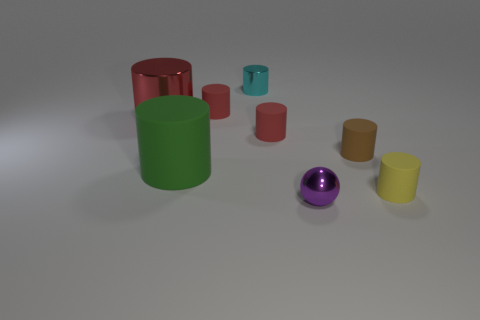How many red cylinders must be subtracted to get 1 red cylinders? 2 Subtract all red blocks. How many red cylinders are left? 3 Subtract all metal cylinders. How many cylinders are left? 5 Subtract 3 cylinders. How many cylinders are left? 4 Subtract all yellow cylinders. How many cylinders are left? 6 Add 1 green cylinders. How many objects exist? 9 Subtract all purple cylinders. Subtract all gray spheres. How many cylinders are left? 7 Add 5 big shiny cylinders. How many big shiny cylinders are left? 6 Add 8 gray shiny balls. How many gray shiny balls exist? 8 Subtract 0 purple cubes. How many objects are left? 8 